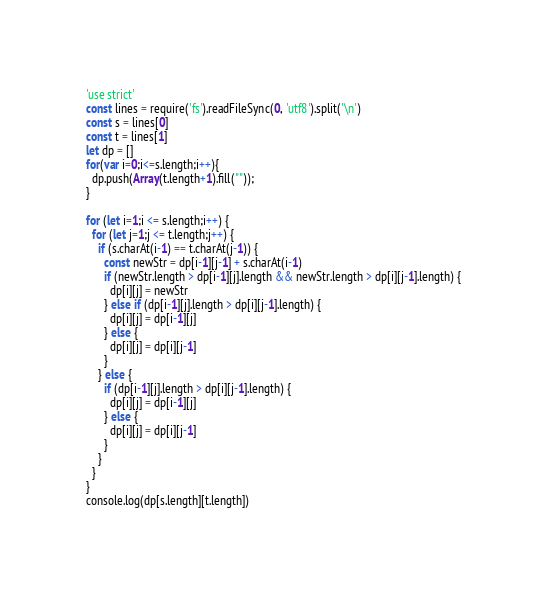<code> <loc_0><loc_0><loc_500><loc_500><_JavaScript_>'use strict'
const lines = require('fs').readFileSync(0, 'utf8').split('\n')
const s = lines[0]
const t = lines[1]
let dp = []
for(var i=0;i<=s.length;i++){
  dp.push(Array(t.length+1).fill(""));
}

for (let i=1;i <= s.length;i++) {
  for (let j=1;j <= t.length;j++) {
    if (s.charAt(i-1) == t.charAt(j-1)) {
      const newStr = dp[i-1][j-1] + s.charAt(i-1)
      if (newStr.length > dp[i-1][j].length && newStr.length > dp[i][j-1].length) {
        dp[i][j] = newStr
      } else if (dp[i-1][j].length > dp[i][j-1].length) {
        dp[i][j] = dp[i-1][j]
      } else {
        dp[i][j] = dp[i][j-1]
      }
    } else {
      if (dp[i-1][j].length > dp[i][j-1].length) {
        dp[i][j] = dp[i-1][j]
      } else {
        dp[i][j] = dp[i][j-1]
      }
    }
  }
}
console.log(dp[s.length][t.length])</code> 